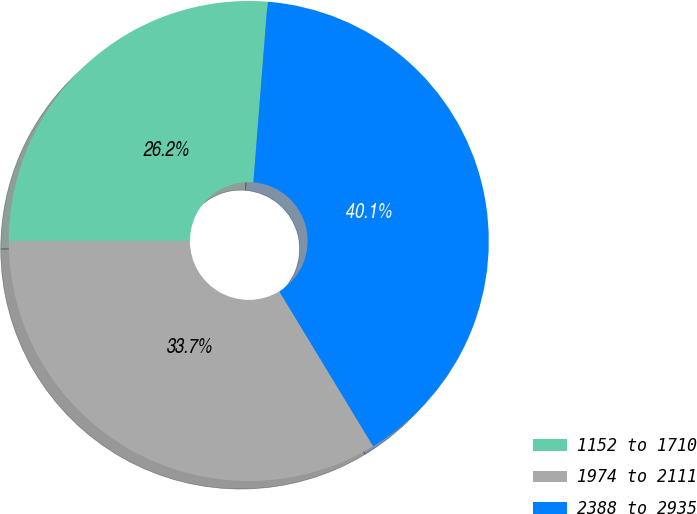Convert chart. <chart><loc_0><loc_0><loc_500><loc_500><pie_chart><fcel>1152 to 1710<fcel>1974 to 2111<fcel>2388 to 2935<nl><fcel>26.25%<fcel>33.68%<fcel>40.08%<nl></chart> 